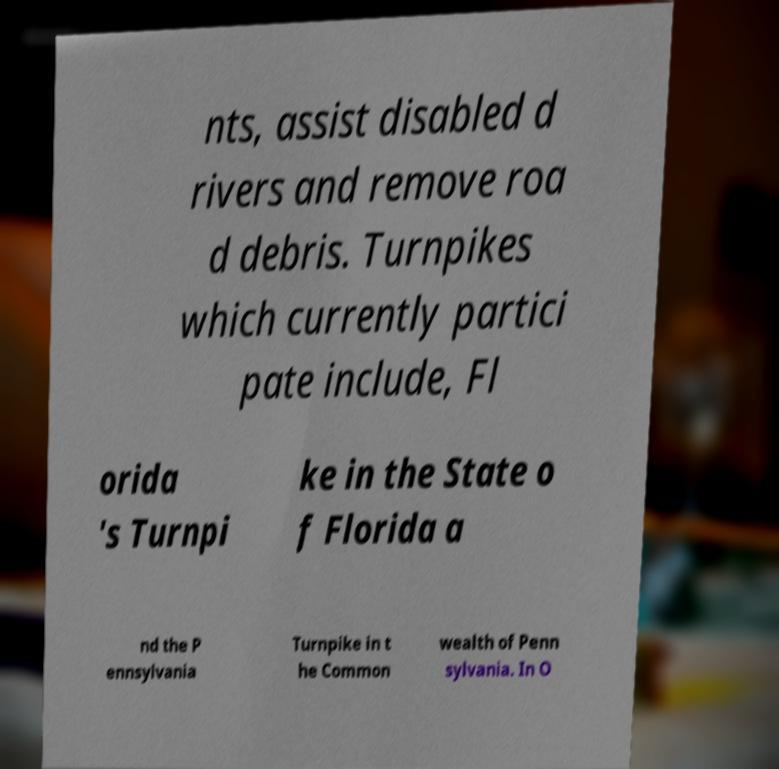Please identify and transcribe the text found in this image. nts, assist disabled d rivers and remove roa d debris. Turnpikes which currently partici pate include, Fl orida 's Turnpi ke in the State o f Florida a nd the P ennsylvania Turnpike in t he Common wealth of Penn sylvania. In O 